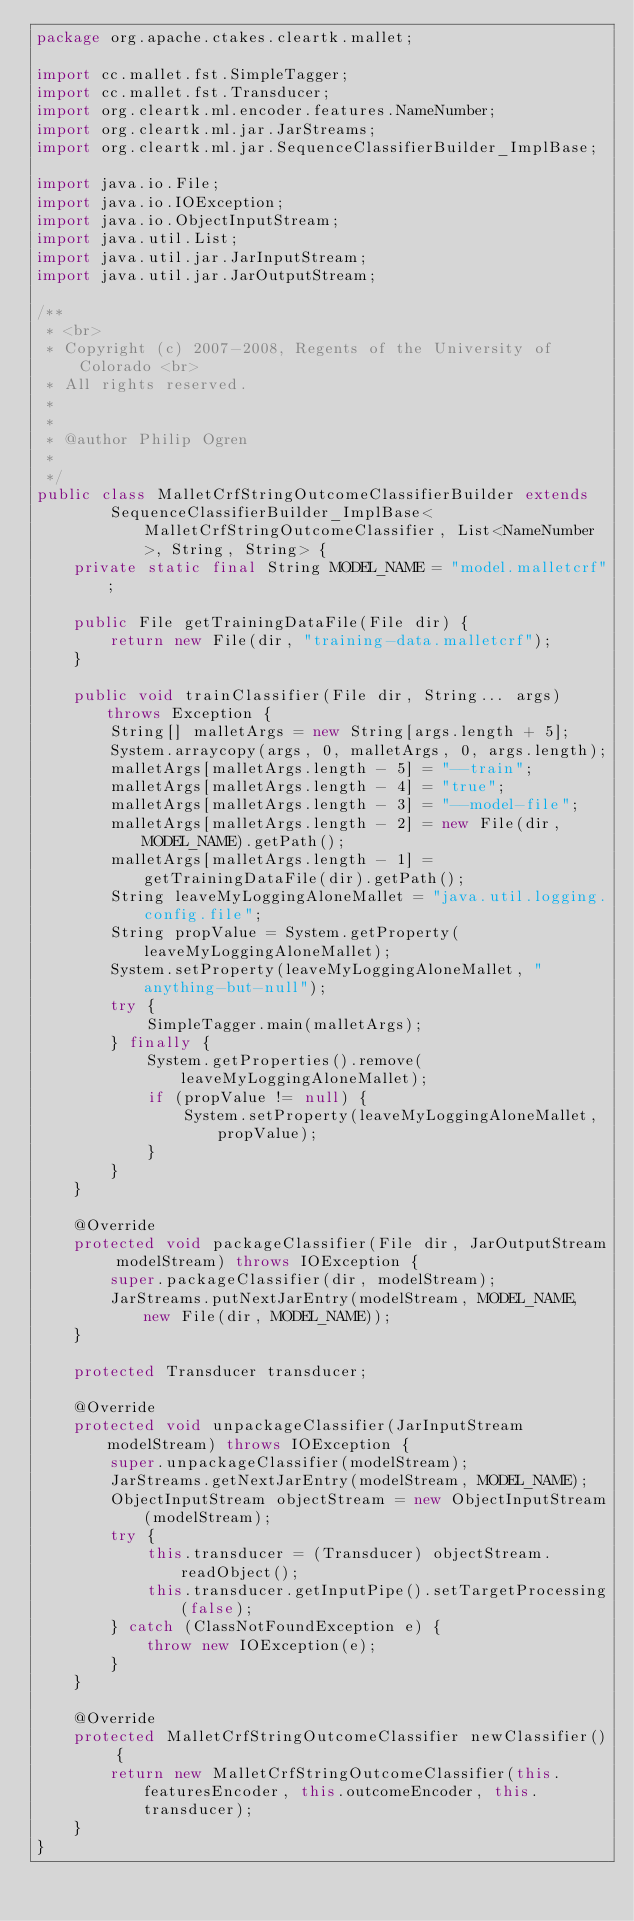Convert code to text. <code><loc_0><loc_0><loc_500><loc_500><_Java_>package org.apache.ctakes.cleartk.mallet;

import cc.mallet.fst.SimpleTagger;
import cc.mallet.fst.Transducer;
import org.cleartk.ml.encoder.features.NameNumber;
import org.cleartk.ml.jar.JarStreams;
import org.cleartk.ml.jar.SequenceClassifierBuilder_ImplBase;

import java.io.File;
import java.io.IOException;
import java.io.ObjectInputStream;
import java.util.List;
import java.util.jar.JarInputStream;
import java.util.jar.JarOutputStream;

/**
 * <br>
 * Copyright (c) 2007-2008, Regents of the University of Colorado <br>
 * All rights reserved.
 *
 *
 * @author Philip Ogren
 *
 */
public class MalletCrfStringOutcomeClassifierBuilder extends
        SequenceClassifierBuilder_ImplBase<MalletCrfStringOutcomeClassifier, List<NameNumber>, String, String> {
    private static final String MODEL_NAME = "model.malletcrf";

    public File getTrainingDataFile(File dir) {
        return new File(dir, "training-data.malletcrf");
    }

    public void trainClassifier(File dir, String... args) throws Exception {
        String[] malletArgs = new String[args.length + 5];
        System.arraycopy(args, 0, malletArgs, 0, args.length);
        malletArgs[malletArgs.length - 5] = "--train";
        malletArgs[malletArgs.length - 4] = "true";
        malletArgs[malletArgs.length - 3] = "--model-file";
        malletArgs[malletArgs.length - 2] = new File(dir, MODEL_NAME).getPath();
        malletArgs[malletArgs.length - 1] = getTrainingDataFile(dir).getPath();
        String leaveMyLoggingAloneMallet = "java.util.logging.config.file";
        String propValue = System.getProperty(leaveMyLoggingAloneMallet);
        System.setProperty(leaveMyLoggingAloneMallet, "anything-but-null");
        try {
            SimpleTagger.main(malletArgs);
        } finally {
            System.getProperties().remove(leaveMyLoggingAloneMallet);
            if (propValue != null) {
                System.setProperty(leaveMyLoggingAloneMallet, propValue);
            }
        }
    }

    @Override
    protected void packageClassifier(File dir, JarOutputStream modelStream) throws IOException {
        super.packageClassifier(dir, modelStream);
        JarStreams.putNextJarEntry(modelStream, MODEL_NAME, new File(dir, MODEL_NAME));
    }

    protected Transducer transducer;

    @Override
    protected void unpackageClassifier(JarInputStream modelStream) throws IOException {
        super.unpackageClassifier(modelStream);
        JarStreams.getNextJarEntry(modelStream, MODEL_NAME);
        ObjectInputStream objectStream = new ObjectInputStream(modelStream);
        try {
            this.transducer = (Transducer) objectStream.readObject();
            this.transducer.getInputPipe().setTargetProcessing(false);
        } catch (ClassNotFoundException e) {
            throw new IOException(e);
        }
    }

    @Override
    protected MalletCrfStringOutcomeClassifier newClassifier() {
        return new MalletCrfStringOutcomeClassifier(this.featuresEncoder, this.outcomeEncoder, this.transducer);
    }
}
</code> 